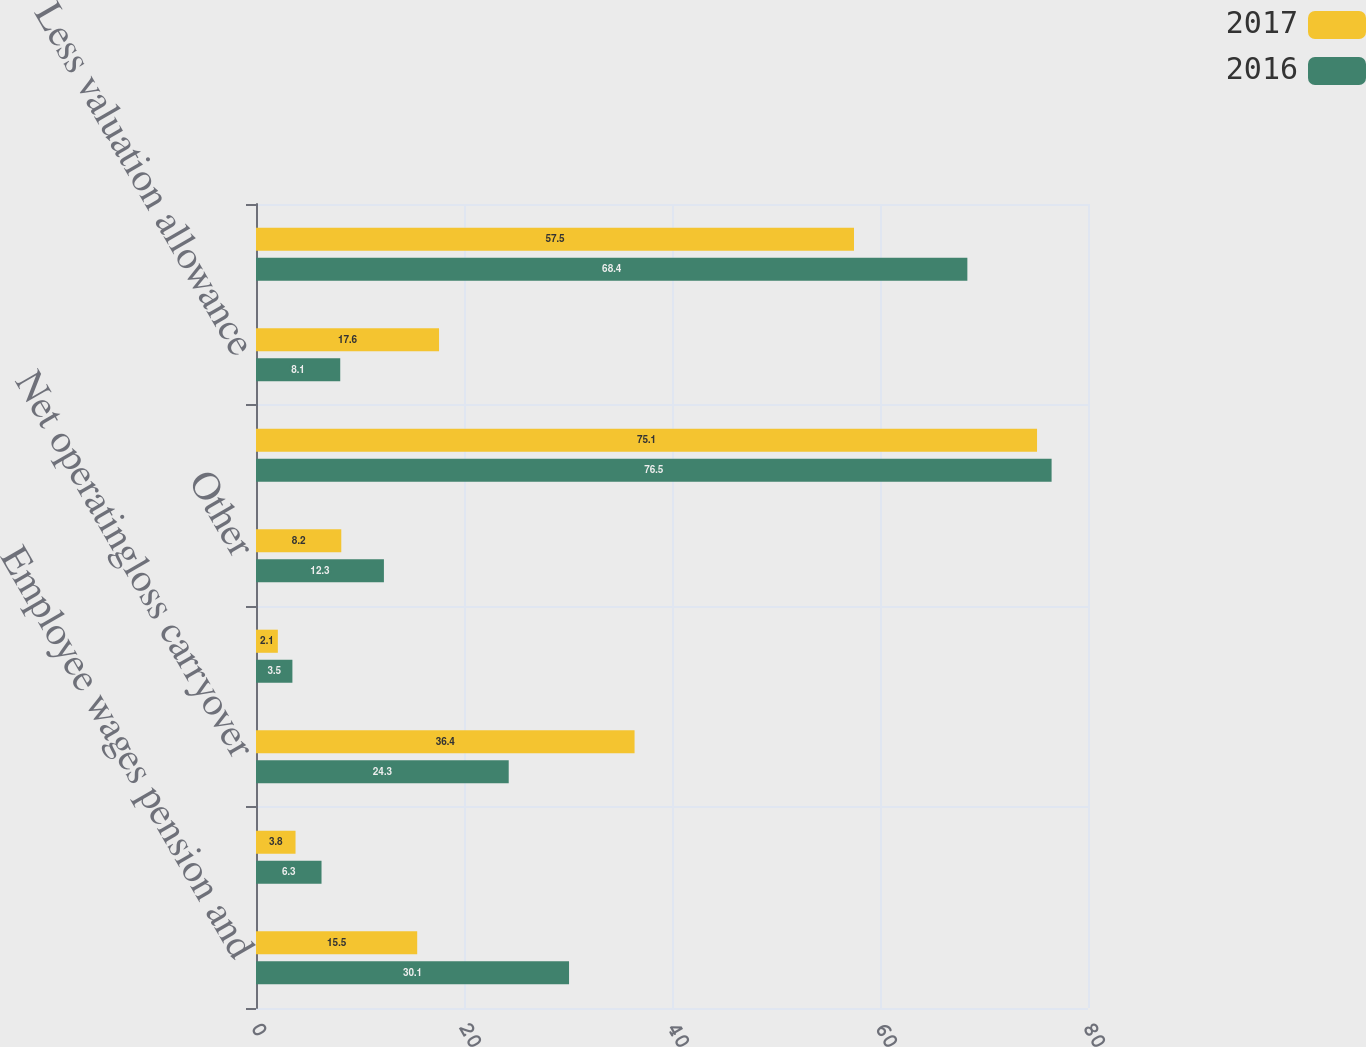<chart> <loc_0><loc_0><loc_500><loc_500><stacked_bar_chart><ecel><fcel>Employee wages pension and<fcel>Deferred rent<fcel>Net operatingloss carryover<fcel>Capital and other<fcel>Other<fcel>Total<fcel>Less valuation allowance<fcel>Deferred incometax asset<nl><fcel>2017<fcel>15.5<fcel>3.8<fcel>36.4<fcel>2.1<fcel>8.2<fcel>75.1<fcel>17.6<fcel>57.5<nl><fcel>2016<fcel>30.1<fcel>6.3<fcel>24.3<fcel>3.5<fcel>12.3<fcel>76.5<fcel>8.1<fcel>68.4<nl></chart> 